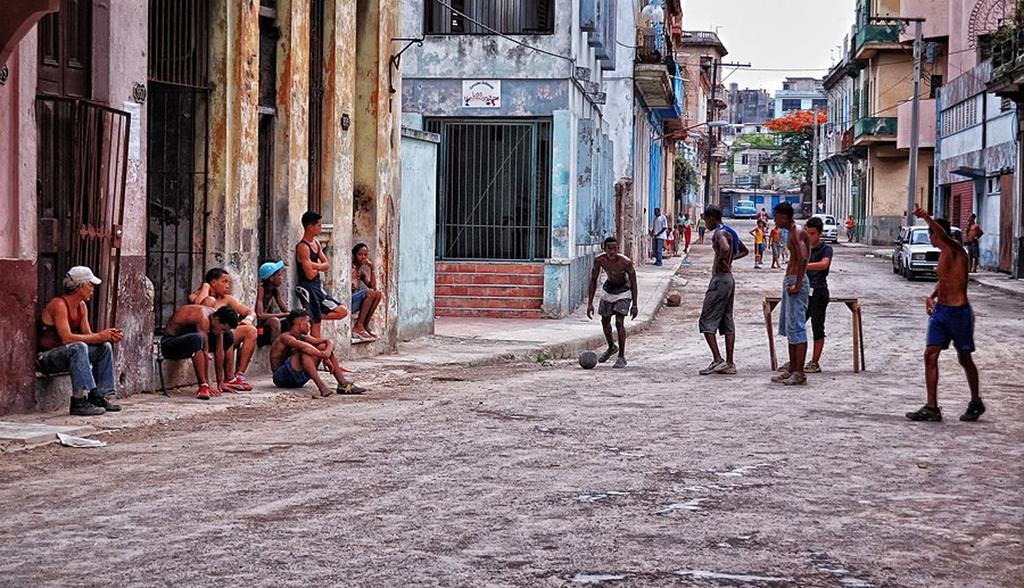Could you give a brief overview of what you see in this image? In this image I can see group of people some are standing and some are sitting. I can see few vehicles on the road, background I can see few buildings, trees in green color, flowers in orange color and sky in white color. 